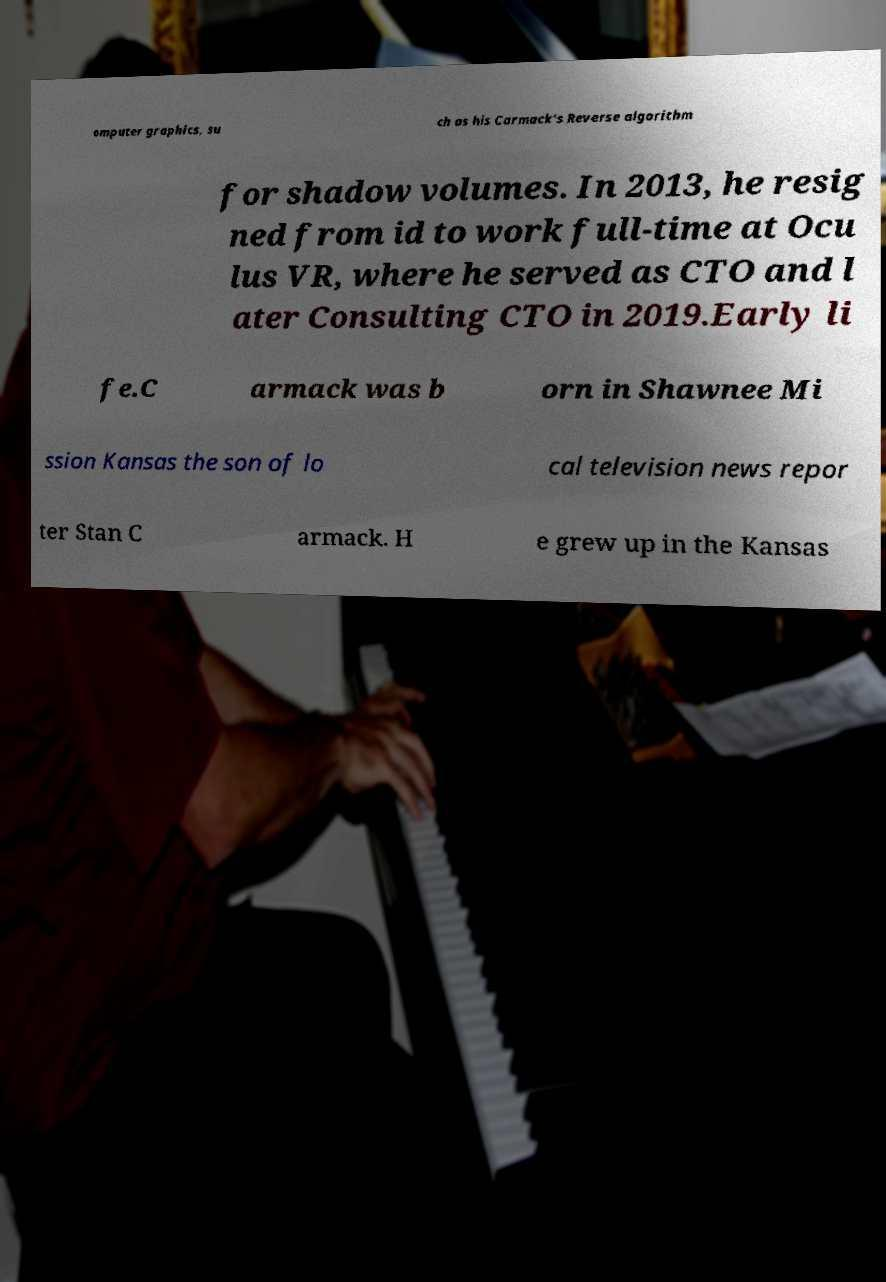Please read and relay the text visible in this image. What does it say? omputer graphics, su ch as his Carmack's Reverse algorithm for shadow volumes. In 2013, he resig ned from id to work full-time at Ocu lus VR, where he served as CTO and l ater Consulting CTO in 2019.Early li fe.C armack was b orn in Shawnee Mi ssion Kansas the son of lo cal television news repor ter Stan C armack. H e grew up in the Kansas 